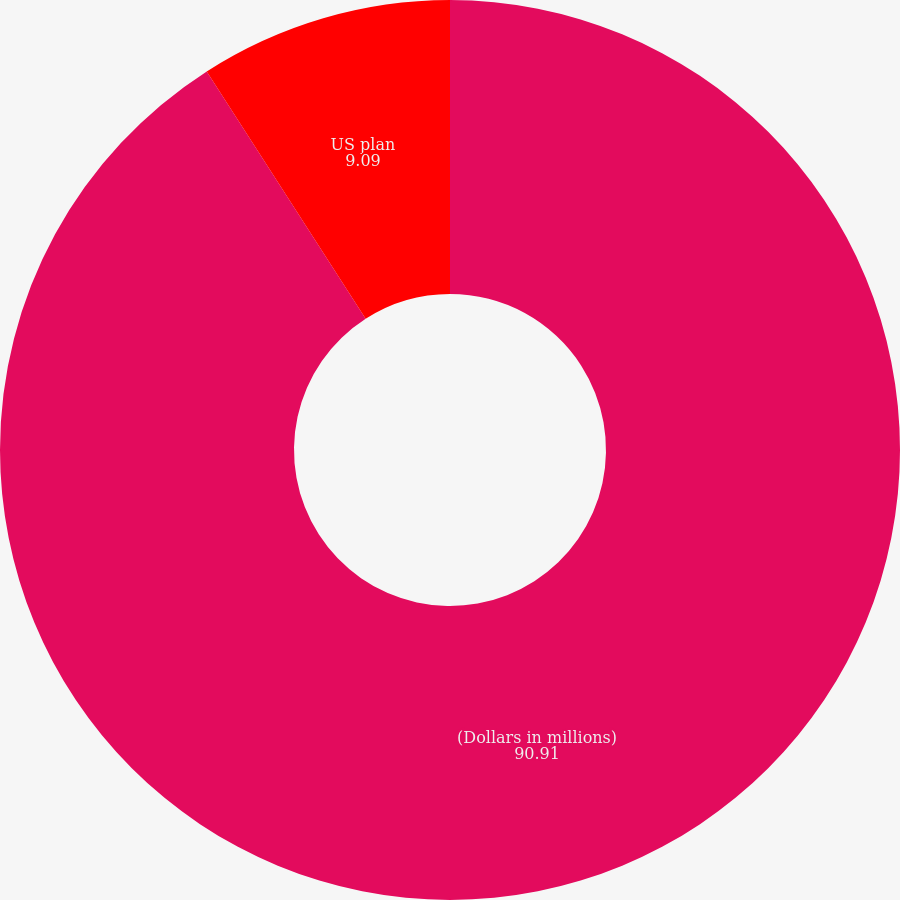Convert chart. <chart><loc_0><loc_0><loc_500><loc_500><pie_chart><fcel>(Dollars in millions)<fcel>US plan<fcel>International plans<nl><fcel>90.91%<fcel>9.09%<fcel>0.0%<nl></chart> 